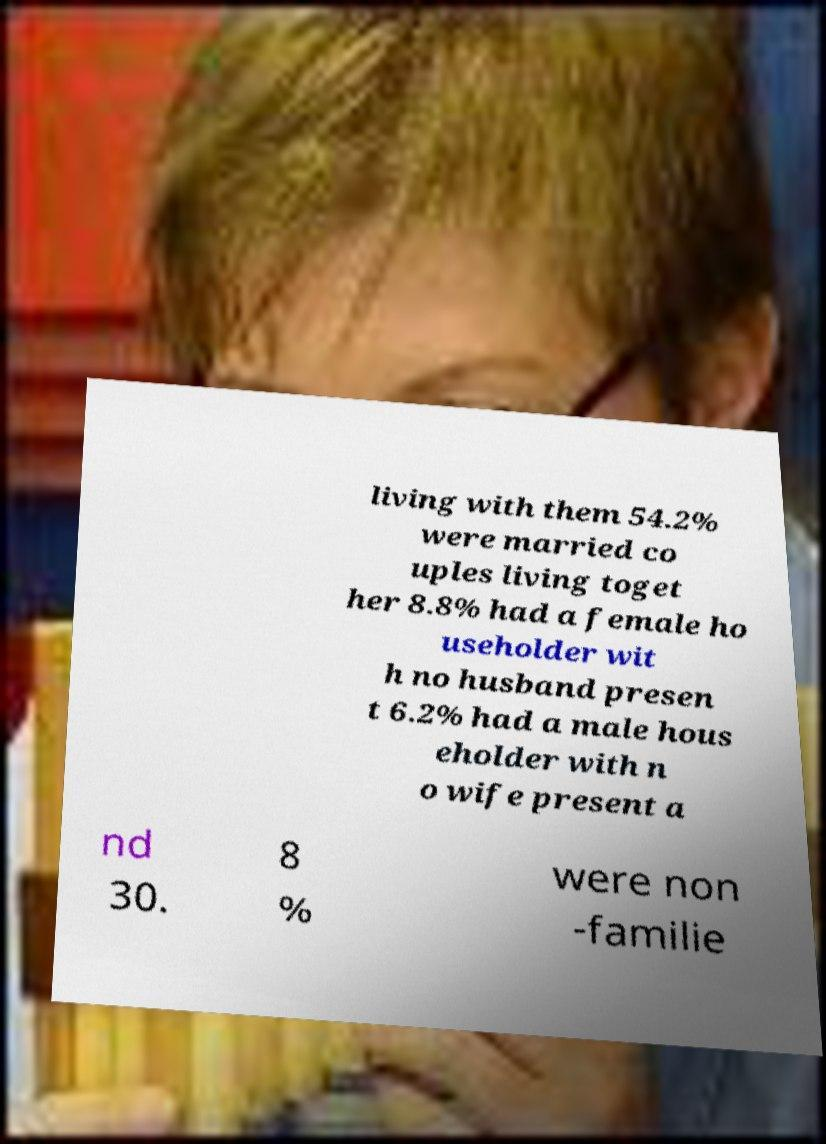Could you assist in decoding the text presented in this image and type it out clearly? living with them 54.2% were married co uples living toget her 8.8% had a female ho useholder wit h no husband presen t 6.2% had a male hous eholder with n o wife present a nd 30. 8 % were non -familie 